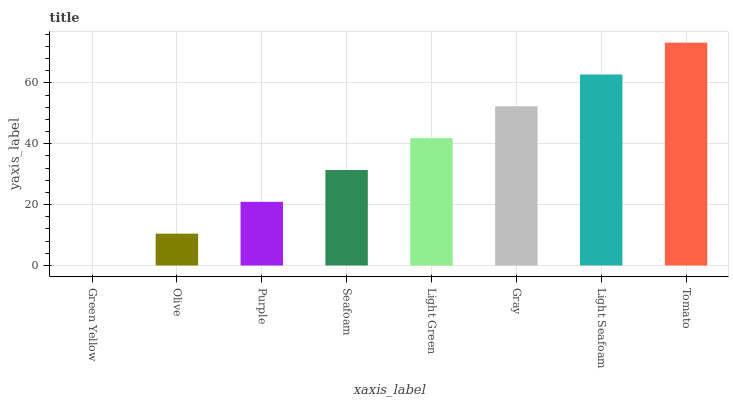Is Olive the minimum?
Answer yes or no. No. Is Olive the maximum?
Answer yes or no. No. Is Olive greater than Green Yellow?
Answer yes or no. Yes. Is Green Yellow less than Olive?
Answer yes or no. Yes. Is Green Yellow greater than Olive?
Answer yes or no. No. Is Olive less than Green Yellow?
Answer yes or no. No. Is Light Green the high median?
Answer yes or no. Yes. Is Seafoam the low median?
Answer yes or no. Yes. Is Seafoam the high median?
Answer yes or no. No. Is Light Seafoam the low median?
Answer yes or no. No. 